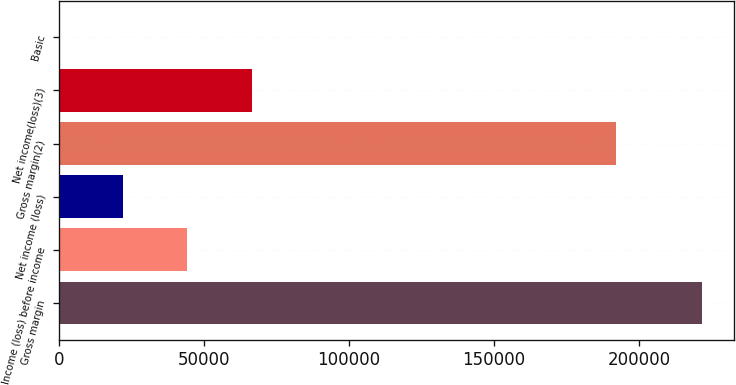Convert chart to OTSL. <chart><loc_0><loc_0><loc_500><loc_500><bar_chart><fcel>Gross margin<fcel>Income (loss) before income<fcel>Net income (loss)<fcel>Gross margin(2)<fcel>Net income(loss)(3)<fcel>Basic<nl><fcel>221763<fcel>44352.7<fcel>22176.4<fcel>192042<fcel>66529<fcel>0.12<nl></chart> 